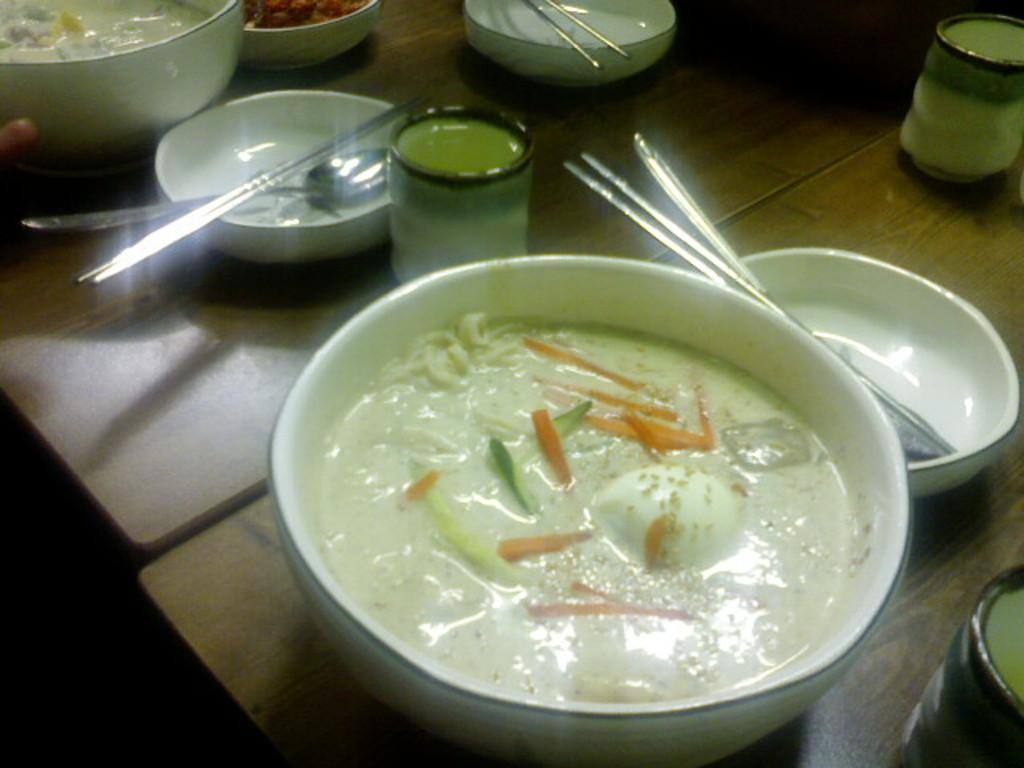What piece of furniture is present in the image? There is a table in the image. What is placed on the table? There are bowls and bottles on the table. What is inside the bowls? There is food in the bowls. What utensils are used with the food in the bowls? There are spoons in the bowls. What crime is being committed in the image? There is no crime being committed in the image; it shows a table with bowls, bottles, food, and spoons. What month is depicted in the image? The image does not depict a specific month; it only shows a table with various items. 